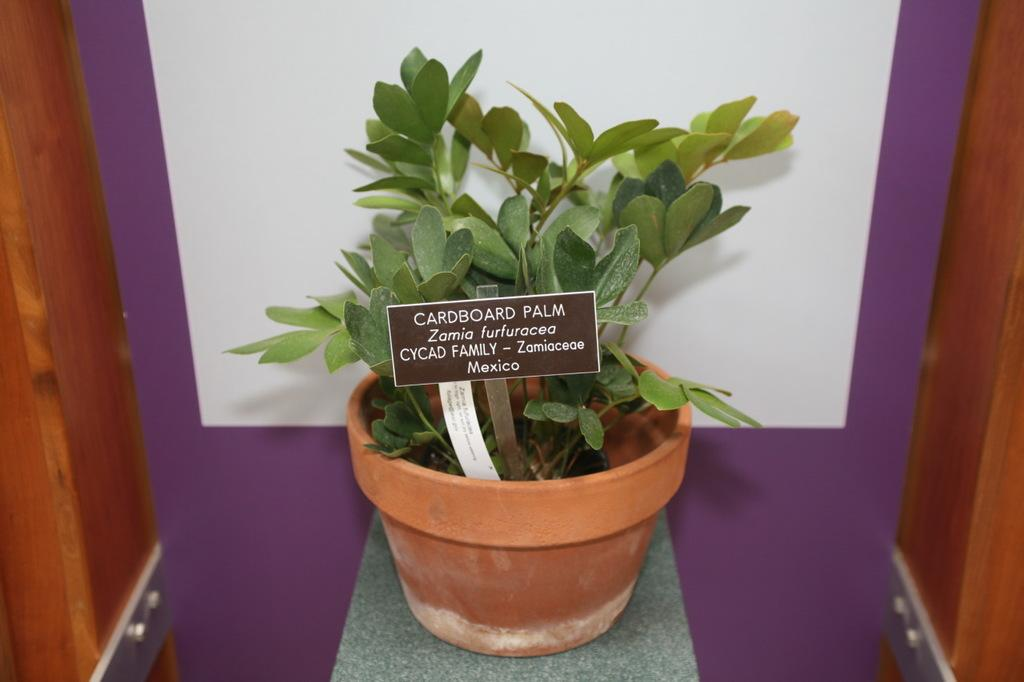What is present in the image? There is a plant in the image. Can you describe the plant in more detail? The plant contains some small boards. What type of patch is visible on the plant in the image? There is no patch visible on the plant in the image. What game can be seen being played on the plant in the image? There is no game being played on the plant in the image. 